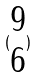<formula> <loc_0><loc_0><loc_500><loc_500>( \begin{matrix} 9 \\ 6 \end{matrix} )</formula> 